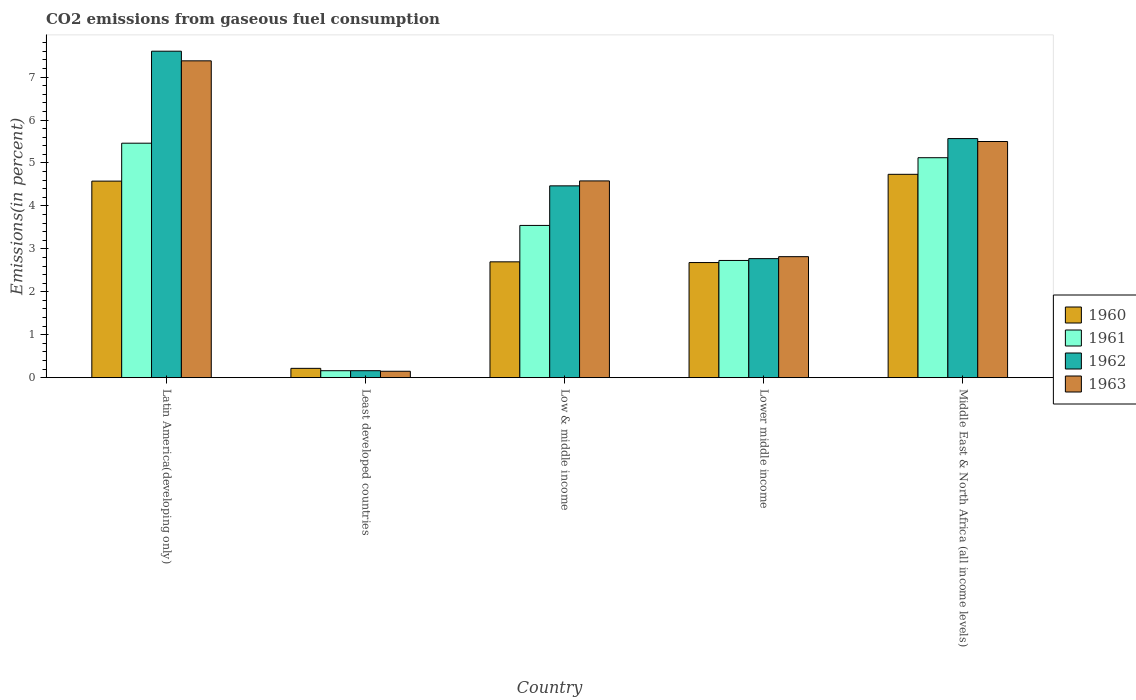How many different coloured bars are there?
Provide a succinct answer. 4. Are the number of bars per tick equal to the number of legend labels?
Provide a succinct answer. Yes. How many bars are there on the 4th tick from the left?
Your answer should be very brief. 4. How many bars are there on the 4th tick from the right?
Ensure brevity in your answer.  4. What is the label of the 5th group of bars from the left?
Your answer should be very brief. Middle East & North Africa (all income levels). What is the total CO2 emitted in 1962 in Low & middle income?
Your answer should be very brief. 4.47. Across all countries, what is the maximum total CO2 emitted in 1963?
Offer a very short reply. 7.38. Across all countries, what is the minimum total CO2 emitted in 1960?
Your answer should be compact. 0.22. In which country was the total CO2 emitted in 1960 maximum?
Provide a succinct answer. Middle East & North Africa (all income levels). In which country was the total CO2 emitted in 1961 minimum?
Your response must be concise. Least developed countries. What is the total total CO2 emitted in 1962 in the graph?
Offer a very short reply. 20.57. What is the difference between the total CO2 emitted in 1961 in Latin America(developing only) and that in Low & middle income?
Keep it short and to the point. 1.92. What is the difference between the total CO2 emitted in 1960 in Lower middle income and the total CO2 emitted in 1961 in Least developed countries?
Your answer should be very brief. 2.52. What is the average total CO2 emitted in 1961 per country?
Make the answer very short. 3.4. What is the difference between the total CO2 emitted of/in 1962 and total CO2 emitted of/in 1960 in Middle East & North Africa (all income levels)?
Make the answer very short. 0.83. In how many countries, is the total CO2 emitted in 1961 greater than 2.2 %?
Ensure brevity in your answer.  4. What is the ratio of the total CO2 emitted in 1962 in Least developed countries to that in Middle East & North Africa (all income levels)?
Make the answer very short. 0.03. Is the difference between the total CO2 emitted in 1962 in Least developed countries and Middle East & North Africa (all income levels) greater than the difference between the total CO2 emitted in 1960 in Least developed countries and Middle East & North Africa (all income levels)?
Offer a terse response. No. What is the difference between the highest and the second highest total CO2 emitted in 1961?
Give a very brief answer. 1.58. What is the difference between the highest and the lowest total CO2 emitted in 1961?
Offer a very short reply. 5.3. Is the sum of the total CO2 emitted in 1960 in Least developed countries and Middle East & North Africa (all income levels) greater than the maximum total CO2 emitted in 1961 across all countries?
Ensure brevity in your answer.  No. Is it the case that in every country, the sum of the total CO2 emitted in 1962 and total CO2 emitted in 1963 is greater than the sum of total CO2 emitted in 1961 and total CO2 emitted in 1960?
Offer a terse response. No. How many bars are there?
Keep it short and to the point. 20. Are all the bars in the graph horizontal?
Keep it short and to the point. No. How many countries are there in the graph?
Provide a short and direct response. 5. What is the difference between two consecutive major ticks on the Y-axis?
Provide a short and direct response. 1. Are the values on the major ticks of Y-axis written in scientific E-notation?
Your answer should be very brief. No. Does the graph contain any zero values?
Offer a very short reply. No. How are the legend labels stacked?
Your answer should be very brief. Vertical. What is the title of the graph?
Offer a very short reply. CO2 emissions from gaseous fuel consumption. Does "1983" appear as one of the legend labels in the graph?
Keep it short and to the point. No. What is the label or title of the X-axis?
Your answer should be compact. Country. What is the label or title of the Y-axis?
Your response must be concise. Emissions(in percent). What is the Emissions(in percent) of 1960 in Latin America(developing only)?
Give a very brief answer. 4.58. What is the Emissions(in percent) in 1961 in Latin America(developing only)?
Offer a terse response. 5.46. What is the Emissions(in percent) in 1962 in Latin America(developing only)?
Offer a very short reply. 7.6. What is the Emissions(in percent) of 1963 in Latin America(developing only)?
Offer a terse response. 7.38. What is the Emissions(in percent) of 1960 in Least developed countries?
Offer a terse response. 0.22. What is the Emissions(in percent) of 1961 in Least developed countries?
Offer a very short reply. 0.16. What is the Emissions(in percent) in 1962 in Least developed countries?
Keep it short and to the point. 0.16. What is the Emissions(in percent) in 1963 in Least developed countries?
Offer a very short reply. 0.15. What is the Emissions(in percent) of 1960 in Low & middle income?
Your answer should be very brief. 2.7. What is the Emissions(in percent) in 1961 in Low & middle income?
Give a very brief answer. 3.55. What is the Emissions(in percent) of 1962 in Low & middle income?
Offer a very short reply. 4.47. What is the Emissions(in percent) of 1963 in Low & middle income?
Offer a terse response. 4.58. What is the Emissions(in percent) in 1960 in Lower middle income?
Your answer should be very brief. 2.68. What is the Emissions(in percent) of 1961 in Lower middle income?
Offer a terse response. 2.73. What is the Emissions(in percent) of 1962 in Lower middle income?
Provide a short and direct response. 2.77. What is the Emissions(in percent) in 1963 in Lower middle income?
Keep it short and to the point. 2.82. What is the Emissions(in percent) of 1960 in Middle East & North Africa (all income levels)?
Keep it short and to the point. 4.74. What is the Emissions(in percent) in 1961 in Middle East & North Africa (all income levels)?
Your answer should be very brief. 5.12. What is the Emissions(in percent) of 1962 in Middle East & North Africa (all income levels)?
Offer a very short reply. 5.57. What is the Emissions(in percent) in 1963 in Middle East & North Africa (all income levels)?
Keep it short and to the point. 5.5. Across all countries, what is the maximum Emissions(in percent) in 1960?
Offer a terse response. 4.74. Across all countries, what is the maximum Emissions(in percent) in 1961?
Keep it short and to the point. 5.46. Across all countries, what is the maximum Emissions(in percent) of 1962?
Keep it short and to the point. 7.6. Across all countries, what is the maximum Emissions(in percent) of 1963?
Your response must be concise. 7.38. Across all countries, what is the minimum Emissions(in percent) of 1960?
Offer a terse response. 0.22. Across all countries, what is the minimum Emissions(in percent) of 1961?
Your response must be concise. 0.16. Across all countries, what is the minimum Emissions(in percent) in 1962?
Ensure brevity in your answer.  0.16. Across all countries, what is the minimum Emissions(in percent) in 1963?
Provide a short and direct response. 0.15. What is the total Emissions(in percent) in 1960 in the graph?
Give a very brief answer. 14.91. What is the total Emissions(in percent) in 1961 in the graph?
Offer a very short reply. 17.02. What is the total Emissions(in percent) in 1962 in the graph?
Offer a terse response. 20.57. What is the total Emissions(in percent) in 1963 in the graph?
Ensure brevity in your answer.  20.43. What is the difference between the Emissions(in percent) of 1960 in Latin America(developing only) and that in Least developed countries?
Make the answer very short. 4.36. What is the difference between the Emissions(in percent) in 1961 in Latin America(developing only) and that in Least developed countries?
Give a very brief answer. 5.3. What is the difference between the Emissions(in percent) in 1962 in Latin America(developing only) and that in Least developed countries?
Your answer should be compact. 7.44. What is the difference between the Emissions(in percent) in 1963 in Latin America(developing only) and that in Least developed countries?
Your response must be concise. 7.23. What is the difference between the Emissions(in percent) in 1960 in Latin America(developing only) and that in Low & middle income?
Offer a very short reply. 1.88. What is the difference between the Emissions(in percent) in 1961 in Latin America(developing only) and that in Low & middle income?
Keep it short and to the point. 1.92. What is the difference between the Emissions(in percent) of 1962 in Latin America(developing only) and that in Low & middle income?
Your answer should be very brief. 3.14. What is the difference between the Emissions(in percent) in 1963 in Latin America(developing only) and that in Low & middle income?
Make the answer very short. 2.8. What is the difference between the Emissions(in percent) of 1960 in Latin America(developing only) and that in Lower middle income?
Offer a very short reply. 1.9. What is the difference between the Emissions(in percent) of 1961 in Latin America(developing only) and that in Lower middle income?
Your answer should be compact. 2.73. What is the difference between the Emissions(in percent) in 1962 in Latin America(developing only) and that in Lower middle income?
Provide a short and direct response. 4.83. What is the difference between the Emissions(in percent) in 1963 in Latin America(developing only) and that in Lower middle income?
Provide a short and direct response. 4.56. What is the difference between the Emissions(in percent) in 1960 in Latin America(developing only) and that in Middle East & North Africa (all income levels)?
Make the answer very short. -0.16. What is the difference between the Emissions(in percent) of 1961 in Latin America(developing only) and that in Middle East & North Africa (all income levels)?
Your response must be concise. 0.34. What is the difference between the Emissions(in percent) of 1962 in Latin America(developing only) and that in Middle East & North Africa (all income levels)?
Offer a very short reply. 2.04. What is the difference between the Emissions(in percent) in 1963 in Latin America(developing only) and that in Middle East & North Africa (all income levels)?
Provide a short and direct response. 1.88. What is the difference between the Emissions(in percent) in 1960 in Least developed countries and that in Low & middle income?
Ensure brevity in your answer.  -2.48. What is the difference between the Emissions(in percent) of 1961 in Least developed countries and that in Low & middle income?
Make the answer very short. -3.38. What is the difference between the Emissions(in percent) in 1962 in Least developed countries and that in Low & middle income?
Keep it short and to the point. -4.31. What is the difference between the Emissions(in percent) of 1963 in Least developed countries and that in Low & middle income?
Keep it short and to the point. -4.43. What is the difference between the Emissions(in percent) of 1960 in Least developed countries and that in Lower middle income?
Provide a short and direct response. -2.46. What is the difference between the Emissions(in percent) in 1961 in Least developed countries and that in Lower middle income?
Ensure brevity in your answer.  -2.57. What is the difference between the Emissions(in percent) in 1962 in Least developed countries and that in Lower middle income?
Your answer should be very brief. -2.61. What is the difference between the Emissions(in percent) in 1963 in Least developed countries and that in Lower middle income?
Provide a succinct answer. -2.67. What is the difference between the Emissions(in percent) in 1960 in Least developed countries and that in Middle East & North Africa (all income levels)?
Offer a terse response. -4.52. What is the difference between the Emissions(in percent) of 1961 in Least developed countries and that in Middle East & North Africa (all income levels)?
Ensure brevity in your answer.  -4.96. What is the difference between the Emissions(in percent) in 1962 in Least developed countries and that in Middle East & North Africa (all income levels)?
Offer a very short reply. -5.41. What is the difference between the Emissions(in percent) of 1963 in Least developed countries and that in Middle East & North Africa (all income levels)?
Your response must be concise. -5.35. What is the difference between the Emissions(in percent) of 1960 in Low & middle income and that in Lower middle income?
Ensure brevity in your answer.  0.02. What is the difference between the Emissions(in percent) in 1961 in Low & middle income and that in Lower middle income?
Provide a short and direct response. 0.82. What is the difference between the Emissions(in percent) in 1962 in Low & middle income and that in Lower middle income?
Keep it short and to the point. 1.7. What is the difference between the Emissions(in percent) of 1963 in Low & middle income and that in Lower middle income?
Your answer should be compact. 1.76. What is the difference between the Emissions(in percent) of 1960 in Low & middle income and that in Middle East & North Africa (all income levels)?
Provide a succinct answer. -2.04. What is the difference between the Emissions(in percent) in 1961 in Low & middle income and that in Middle East & North Africa (all income levels)?
Keep it short and to the point. -1.58. What is the difference between the Emissions(in percent) in 1962 in Low & middle income and that in Middle East & North Africa (all income levels)?
Make the answer very short. -1.1. What is the difference between the Emissions(in percent) in 1963 in Low & middle income and that in Middle East & North Africa (all income levels)?
Provide a short and direct response. -0.92. What is the difference between the Emissions(in percent) in 1960 in Lower middle income and that in Middle East & North Africa (all income levels)?
Make the answer very short. -2.06. What is the difference between the Emissions(in percent) of 1961 in Lower middle income and that in Middle East & North Africa (all income levels)?
Your response must be concise. -2.39. What is the difference between the Emissions(in percent) in 1962 in Lower middle income and that in Middle East & North Africa (all income levels)?
Your answer should be very brief. -2.8. What is the difference between the Emissions(in percent) of 1963 in Lower middle income and that in Middle East & North Africa (all income levels)?
Your answer should be compact. -2.68. What is the difference between the Emissions(in percent) of 1960 in Latin America(developing only) and the Emissions(in percent) of 1961 in Least developed countries?
Offer a very short reply. 4.42. What is the difference between the Emissions(in percent) in 1960 in Latin America(developing only) and the Emissions(in percent) in 1962 in Least developed countries?
Give a very brief answer. 4.42. What is the difference between the Emissions(in percent) in 1960 in Latin America(developing only) and the Emissions(in percent) in 1963 in Least developed countries?
Offer a terse response. 4.43. What is the difference between the Emissions(in percent) in 1961 in Latin America(developing only) and the Emissions(in percent) in 1962 in Least developed countries?
Your response must be concise. 5.3. What is the difference between the Emissions(in percent) in 1961 in Latin America(developing only) and the Emissions(in percent) in 1963 in Least developed countries?
Your answer should be compact. 5.31. What is the difference between the Emissions(in percent) of 1962 in Latin America(developing only) and the Emissions(in percent) of 1963 in Least developed countries?
Keep it short and to the point. 7.45. What is the difference between the Emissions(in percent) in 1960 in Latin America(developing only) and the Emissions(in percent) in 1961 in Low & middle income?
Provide a succinct answer. 1.03. What is the difference between the Emissions(in percent) of 1960 in Latin America(developing only) and the Emissions(in percent) of 1962 in Low & middle income?
Offer a terse response. 0.11. What is the difference between the Emissions(in percent) of 1960 in Latin America(developing only) and the Emissions(in percent) of 1963 in Low & middle income?
Your answer should be compact. -0. What is the difference between the Emissions(in percent) in 1961 in Latin America(developing only) and the Emissions(in percent) in 1962 in Low & middle income?
Your response must be concise. 0.99. What is the difference between the Emissions(in percent) of 1961 in Latin America(developing only) and the Emissions(in percent) of 1963 in Low & middle income?
Offer a very short reply. 0.88. What is the difference between the Emissions(in percent) in 1962 in Latin America(developing only) and the Emissions(in percent) in 1963 in Low & middle income?
Ensure brevity in your answer.  3.02. What is the difference between the Emissions(in percent) of 1960 in Latin America(developing only) and the Emissions(in percent) of 1961 in Lower middle income?
Make the answer very short. 1.85. What is the difference between the Emissions(in percent) in 1960 in Latin America(developing only) and the Emissions(in percent) in 1962 in Lower middle income?
Keep it short and to the point. 1.81. What is the difference between the Emissions(in percent) of 1960 in Latin America(developing only) and the Emissions(in percent) of 1963 in Lower middle income?
Offer a terse response. 1.76. What is the difference between the Emissions(in percent) in 1961 in Latin America(developing only) and the Emissions(in percent) in 1962 in Lower middle income?
Ensure brevity in your answer.  2.69. What is the difference between the Emissions(in percent) in 1961 in Latin America(developing only) and the Emissions(in percent) in 1963 in Lower middle income?
Your response must be concise. 2.64. What is the difference between the Emissions(in percent) of 1962 in Latin America(developing only) and the Emissions(in percent) of 1963 in Lower middle income?
Keep it short and to the point. 4.79. What is the difference between the Emissions(in percent) in 1960 in Latin America(developing only) and the Emissions(in percent) in 1961 in Middle East & North Africa (all income levels)?
Keep it short and to the point. -0.54. What is the difference between the Emissions(in percent) of 1960 in Latin America(developing only) and the Emissions(in percent) of 1962 in Middle East & North Africa (all income levels)?
Keep it short and to the point. -0.99. What is the difference between the Emissions(in percent) of 1960 in Latin America(developing only) and the Emissions(in percent) of 1963 in Middle East & North Africa (all income levels)?
Keep it short and to the point. -0.92. What is the difference between the Emissions(in percent) of 1961 in Latin America(developing only) and the Emissions(in percent) of 1962 in Middle East & North Africa (all income levels)?
Ensure brevity in your answer.  -0.11. What is the difference between the Emissions(in percent) in 1961 in Latin America(developing only) and the Emissions(in percent) in 1963 in Middle East & North Africa (all income levels)?
Provide a short and direct response. -0.04. What is the difference between the Emissions(in percent) in 1962 in Latin America(developing only) and the Emissions(in percent) in 1963 in Middle East & North Africa (all income levels)?
Your answer should be compact. 2.1. What is the difference between the Emissions(in percent) of 1960 in Least developed countries and the Emissions(in percent) of 1961 in Low & middle income?
Offer a terse response. -3.33. What is the difference between the Emissions(in percent) of 1960 in Least developed countries and the Emissions(in percent) of 1962 in Low & middle income?
Provide a short and direct response. -4.25. What is the difference between the Emissions(in percent) of 1960 in Least developed countries and the Emissions(in percent) of 1963 in Low & middle income?
Provide a succinct answer. -4.37. What is the difference between the Emissions(in percent) in 1961 in Least developed countries and the Emissions(in percent) in 1962 in Low & middle income?
Offer a terse response. -4.31. What is the difference between the Emissions(in percent) of 1961 in Least developed countries and the Emissions(in percent) of 1963 in Low & middle income?
Give a very brief answer. -4.42. What is the difference between the Emissions(in percent) of 1962 in Least developed countries and the Emissions(in percent) of 1963 in Low & middle income?
Your answer should be compact. -4.42. What is the difference between the Emissions(in percent) in 1960 in Least developed countries and the Emissions(in percent) in 1961 in Lower middle income?
Ensure brevity in your answer.  -2.51. What is the difference between the Emissions(in percent) of 1960 in Least developed countries and the Emissions(in percent) of 1962 in Lower middle income?
Ensure brevity in your answer.  -2.56. What is the difference between the Emissions(in percent) in 1960 in Least developed countries and the Emissions(in percent) in 1963 in Lower middle income?
Provide a short and direct response. -2.6. What is the difference between the Emissions(in percent) in 1961 in Least developed countries and the Emissions(in percent) in 1962 in Lower middle income?
Make the answer very short. -2.61. What is the difference between the Emissions(in percent) in 1961 in Least developed countries and the Emissions(in percent) in 1963 in Lower middle income?
Your response must be concise. -2.66. What is the difference between the Emissions(in percent) of 1962 in Least developed countries and the Emissions(in percent) of 1963 in Lower middle income?
Provide a succinct answer. -2.66. What is the difference between the Emissions(in percent) in 1960 in Least developed countries and the Emissions(in percent) in 1961 in Middle East & North Africa (all income levels)?
Offer a terse response. -4.91. What is the difference between the Emissions(in percent) in 1960 in Least developed countries and the Emissions(in percent) in 1962 in Middle East & North Africa (all income levels)?
Your answer should be compact. -5.35. What is the difference between the Emissions(in percent) of 1960 in Least developed countries and the Emissions(in percent) of 1963 in Middle East & North Africa (all income levels)?
Provide a succinct answer. -5.28. What is the difference between the Emissions(in percent) in 1961 in Least developed countries and the Emissions(in percent) in 1962 in Middle East & North Africa (all income levels)?
Make the answer very short. -5.41. What is the difference between the Emissions(in percent) of 1961 in Least developed countries and the Emissions(in percent) of 1963 in Middle East & North Africa (all income levels)?
Provide a short and direct response. -5.34. What is the difference between the Emissions(in percent) of 1962 in Least developed countries and the Emissions(in percent) of 1963 in Middle East & North Africa (all income levels)?
Your answer should be compact. -5.34. What is the difference between the Emissions(in percent) in 1960 in Low & middle income and the Emissions(in percent) in 1961 in Lower middle income?
Your answer should be very brief. -0.03. What is the difference between the Emissions(in percent) of 1960 in Low & middle income and the Emissions(in percent) of 1962 in Lower middle income?
Your answer should be very brief. -0.07. What is the difference between the Emissions(in percent) in 1960 in Low & middle income and the Emissions(in percent) in 1963 in Lower middle income?
Your response must be concise. -0.12. What is the difference between the Emissions(in percent) of 1961 in Low & middle income and the Emissions(in percent) of 1962 in Lower middle income?
Provide a short and direct response. 0.77. What is the difference between the Emissions(in percent) in 1961 in Low & middle income and the Emissions(in percent) in 1963 in Lower middle income?
Provide a short and direct response. 0.73. What is the difference between the Emissions(in percent) of 1962 in Low & middle income and the Emissions(in percent) of 1963 in Lower middle income?
Offer a very short reply. 1.65. What is the difference between the Emissions(in percent) in 1960 in Low & middle income and the Emissions(in percent) in 1961 in Middle East & North Africa (all income levels)?
Your answer should be compact. -2.42. What is the difference between the Emissions(in percent) in 1960 in Low & middle income and the Emissions(in percent) in 1962 in Middle East & North Africa (all income levels)?
Keep it short and to the point. -2.87. What is the difference between the Emissions(in percent) of 1960 in Low & middle income and the Emissions(in percent) of 1963 in Middle East & North Africa (all income levels)?
Your answer should be very brief. -2.8. What is the difference between the Emissions(in percent) of 1961 in Low & middle income and the Emissions(in percent) of 1962 in Middle East & North Africa (all income levels)?
Your answer should be compact. -2.02. What is the difference between the Emissions(in percent) of 1961 in Low & middle income and the Emissions(in percent) of 1963 in Middle East & North Africa (all income levels)?
Provide a short and direct response. -1.95. What is the difference between the Emissions(in percent) of 1962 in Low & middle income and the Emissions(in percent) of 1963 in Middle East & North Africa (all income levels)?
Your answer should be compact. -1.03. What is the difference between the Emissions(in percent) in 1960 in Lower middle income and the Emissions(in percent) in 1961 in Middle East & North Africa (all income levels)?
Provide a short and direct response. -2.44. What is the difference between the Emissions(in percent) of 1960 in Lower middle income and the Emissions(in percent) of 1962 in Middle East & North Africa (all income levels)?
Give a very brief answer. -2.89. What is the difference between the Emissions(in percent) in 1960 in Lower middle income and the Emissions(in percent) in 1963 in Middle East & North Africa (all income levels)?
Keep it short and to the point. -2.82. What is the difference between the Emissions(in percent) of 1961 in Lower middle income and the Emissions(in percent) of 1962 in Middle East & North Africa (all income levels)?
Make the answer very short. -2.84. What is the difference between the Emissions(in percent) in 1961 in Lower middle income and the Emissions(in percent) in 1963 in Middle East & North Africa (all income levels)?
Provide a short and direct response. -2.77. What is the difference between the Emissions(in percent) in 1962 in Lower middle income and the Emissions(in percent) in 1963 in Middle East & North Africa (all income levels)?
Make the answer very short. -2.73. What is the average Emissions(in percent) in 1960 per country?
Provide a short and direct response. 2.98. What is the average Emissions(in percent) in 1961 per country?
Provide a short and direct response. 3.4. What is the average Emissions(in percent) in 1962 per country?
Ensure brevity in your answer.  4.11. What is the average Emissions(in percent) in 1963 per country?
Offer a very short reply. 4.09. What is the difference between the Emissions(in percent) in 1960 and Emissions(in percent) in 1961 in Latin America(developing only)?
Give a very brief answer. -0.88. What is the difference between the Emissions(in percent) in 1960 and Emissions(in percent) in 1962 in Latin America(developing only)?
Your answer should be very brief. -3.03. What is the difference between the Emissions(in percent) of 1960 and Emissions(in percent) of 1963 in Latin America(developing only)?
Provide a succinct answer. -2.8. What is the difference between the Emissions(in percent) of 1961 and Emissions(in percent) of 1962 in Latin America(developing only)?
Offer a terse response. -2.14. What is the difference between the Emissions(in percent) of 1961 and Emissions(in percent) of 1963 in Latin America(developing only)?
Provide a succinct answer. -1.92. What is the difference between the Emissions(in percent) of 1962 and Emissions(in percent) of 1963 in Latin America(developing only)?
Ensure brevity in your answer.  0.22. What is the difference between the Emissions(in percent) in 1960 and Emissions(in percent) in 1961 in Least developed countries?
Your answer should be compact. 0.05. What is the difference between the Emissions(in percent) in 1960 and Emissions(in percent) in 1962 in Least developed countries?
Provide a short and direct response. 0.05. What is the difference between the Emissions(in percent) of 1960 and Emissions(in percent) of 1963 in Least developed countries?
Your response must be concise. 0.07. What is the difference between the Emissions(in percent) in 1961 and Emissions(in percent) in 1962 in Least developed countries?
Give a very brief answer. -0. What is the difference between the Emissions(in percent) of 1961 and Emissions(in percent) of 1963 in Least developed countries?
Offer a very short reply. 0.01. What is the difference between the Emissions(in percent) of 1962 and Emissions(in percent) of 1963 in Least developed countries?
Your response must be concise. 0.01. What is the difference between the Emissions(in percent) of 1960 and Emissions(in percent) of 1961 in Low & middle income?
Ensure brevity in your answer.  -0.85. What is the difference between the Emissions(in percent) of 1960 and Emissions(in percent) of 1962 in Low & middle income?
Ensure brevity in your answer.  -1.77. What is the difference between the Emissions(in percent) of 1960 and Emissions(in percent) of 1963 in Low & middle income?
Give a very brief answer. -1.88. What is the difference between the Emissions(in percent) of 1961 and Emissions(in percent) of 1962 in Low & middle income?
Your response must be concise. -0.92. What is the difference between the Emissions(in percent) of 1961 and Emissions(in percent) of 1963 in Low & middle income?
Keep it short and to the point. -1.04. What is the difference between the Emissions(in percent) of 1962 and Emissions(in percent) of 1963 in Low & middle income?
Keep it short and to the point. -0.12. What is the difference between the Emissions(in percent) of 1960 and Emissions(in percent) of 1961 in Lower middle income?
Provide a succinct answer. -0.05. What is the difference between the Emissions(in percent) of 1960 and Emissions(in percent) of 1962 in Lower middle income?
Your response must be concise. -0.09. What is the difference between the Emissions(in percent) of 1960 and Emissions(in percent) of 1963 in Lower middle income?
Provide a short and direct response. -0.14. What is the difference between the Emissions(in percent) of 1961 and Emissions(in percent) of 1962 in Lower middle income?
Make the answer very short. -0.04. What is the difference between the Emissions(in percent) of 1961 and Emissions(in percent) of 1963 in Lower middle income?
Ensure brevity in your answer.  -0.09. What is the difference between the Emissions(in percent) of 1962 and Emissions(in percent) of 1963 in Lower middle income?
Make the answer very short. -0.05. What is the difference between the Emissions(in percent) in 1960 and Emissions(in percent) in 1961 in Middle East & North Africa (all income levels)?
Your response must be concise. -0.39. What is the difference between the Emissions(in percent) in 1960 and Emissions(in percent) in 1962 in Middle East & North Africa (all income levels)?
Your response must be concise. -0.83. What is the difference between the Emissions(in percent) of 1960 and Emissions(in percent) of 1963 in Middle East & North Africa (all income levels)?
Offer a very short reply. -0.76. What is the difference between the Emissions(in percent) of 1961 and Emissions(in percent) of 1962 in Middle East & North Africa (all income levels)?
Offer a terse response. -0.45. What is the difference between the Emissions(in percent) of 1961 and Emissions(in percent) of 1963 in Middle East & North Africa (all income levels)?
Give a very brief answer. -0.38. What is the difference between the Emissions(in percent) of 1962 and Emissions(in percent) of 1963 in Middle East & North Africa (all income levels)?
Your response must be concise. 0.07. What is the ratio of the Emissions(in percent) of 1960 in Latin America(developing only) to that in Least developed countries?
Provide a short and direct response. 21.12. What is the ratio of the Emissions(in percent) of 1961 in Latin America(developing only) to that in Least developed countries?
Offer a very short reply. 33.71. What is the ratio of the Emissions(in percent) of 1962 in Latin America(developing only) to that in Least developed countries?
Ensure brevity in your answer.  46.89. What is the ratio of the Emissions(in percent) in 1963 in Latin America(developing only) to that in Least developed countries?
Keep it short and to the point. 49.45. What is the ratio of the Emissions(in percent) in 1960 in Latin America(developing only) to that in Low & middle income?
Offer a terse response. 1.7. What is the ratio of the Emissions(in percent) of 1961 in Latin America(developing only) to that in Low & middle income?
Your response must be concise. 1.54. What is the ratio of the Emissions(in percent) of 1962 in Latin America(developing only) to that in Low & middle income?
Give a very brief answer. 1.7. What is the ratio of the Emissions(in percent) of 1963 in Latin America(developing only) to that in Low & middle income?
Your answer should be very brief. 1.61. What is the ratio of the Emissions(in percent) of 1960 in Latin America(developing only) to that in Lower middle income?
Your answer should be compact. 1.71. What is the ratio of the Emissions(in percent) of 1961 in Latin America(developing only) to that in Lower middle income?
Make the answer very short. 2. What is the ratio of the Emissions(in percent) in 1962 in Latin America(developing only) to that in Lower middle income?
Your answer should be compact. 2.74. What is the ratio of the Emissions(in percent) in 1963 in Latin America(developing only) to that in Lower middle income?
Give a very brief answer. 2.62. What is the ratio of the Emissions(in percent) in 1960 in Latin America(developing only) to that in Middle East & North Africa (all income levels)?
Your answer should be compact. 0.97. What is the ratio of the Emissions(in percent) of 1961 in Latin America(developing only) to that in Middle East & North Africa (all income levels)?
Offer a very short reply. 1.07. What is the ratio of the Emissions(in percent) of 1962 in Latin America(developing only) to that in Middle East & North Africa (all income levels)?
Offer a terse response. 1.37. What is the ratio of the Emissions(in percent) in 1963 in Latin America(developing only) to that in Middle East & North Africa (all income levels)?
Your answer should be very brief. 1.34. What is the ratio of the Emissions(in percent) of 1960 in Least developed countries to that in Low & middle income?
Your answer should be compact. 0.08. What is the ratio of the Emissions(in percent) of 1961 in Least developed countries to that in Low & middle income?
Offer a terse response. 0.05. What is the ratio of the Emissions(in percent) of 1962 in Least developed countries to that in Low & middle income?
Keep it short and to the point. 0.04. What is the ratio of the Emissions(in percent) in 1963 in Least developed countries to that in Low & middle income?
Keep it short and to the point. 0.03. What is the ratio of the Emissions(in percent) in 1960 in Least developed countries to that in Lower middle income?
Provide a short and direct response. 0.08. What is the ratio of the Emissions(in percent) in 1961 in Least developed countries to that in Lower middle income?
Give a very brief answer. 0.06. What is the ratio of the Emissions(in percent) of 1962 in Least developed countries to that in Lower middle income?
Keep it short and to the point. 0.06. What is the ratio of the Emissions(in percent) of 1963 in Least developed countries to that in Lower middle income?
Keep it short and to the point. 0.05. What is the ratio of the Emissions(in percent) in 1960 in Least developed countries to that in Middle East & North Africa (all income levels)?
Your answer should be compact. 0.05. What is the ratio of the Emissions(in percent) of 1961 in Least developed countries to that in Middle East & North Africa (all income levels)?
Your answer should be compact. 0.03. What is the ratio of the Emissions(in percent) in 1962 in Least developed countries to that in Middle East & North Africa (all income levels)?
Your answer should be very brief. 0.03. What is the ratio of the Emissions(in percent) in 1963 in Least developed countries to that in Middle East & North Africa (all income levels)?
Keep it short and to the point. 0.03. What is the ratio of the Emissions(in percent) of 1960 in Low & middle income to that in Lower middle income?
Your answer should be very brief. 1.01. What is the ratio of the Emissions(in percent) in 1961 in Low & middle income to that in Lower middle income?
Ensure brevity in your answer.  1.3. What is the ratio of the Emissions(in percent) of 1962 in Low & middle income to that in Lower middle income?
Offer a terse response. 1.61. What is the ratio of the Emissions(in percent) in 1963 in Low & middle income to that in Lower middle income?
Keep it short and to the point. 1.63. What is the ratio of the Emissions(in percent) in 1960 in Low & middle income to that in Middle East & North Africa (all income levels)?
Give a very brief answer. 0.57. What is the ratio of the Emissions(in percent) of 1961 in Low & middle income to that in Middle East & North Africa (all income levels)?
Your response must be concise. 0.69. What is the ratio of the Emissions(in percent) in 1962 in Low & middle income to that in Middle East & North Africa (all income levels)?
Your answer should be compact. 0.8. What is the ratio of the Emissions(in percent) in 1963 in Low & middle income to that in Middle East & North Africa (all income levels)?
Your answer should be very brief. 0.83. What is the ratio of the Emissions(in percent) in 1960 in Lower middle income to that in Middle East & North Africa (all income levels)?
Provide a succinct answer. 0.57. What is the ratio of the Emissions(in percent) in 1961 in Lower middle income to that in Middle East & North Africa (all income levels)?
Your response must be concise. 0.53. What is the ratio of the Emissions(in percent) of 1962 in Lower middle income to that in Middle East & North Africa (all income levels)?
Offer a very short reply. 0.5. What is the ratio of the Emissions(in percent) of 1963 in Lower middle income to that in Middle East & North Africa (all income levels)?
Provide a succinct answer. 0.51. What is the difference between the highest and the second highest Emissions(in percent) of 1960?
Offer a terse response. 0.16. What is the difference between the highest and the second highest Emissions(in percent) of 1961?
Give a very brief answer. 0.34. What is the difference between the highest and the second highest Emissions(in percent) of 1962?
Ensure brevity in your answer.  2.04. What is the difference between the highest and the second highest Emissions(in percent) in 1963?
Your response must be concise. 1.88. What is the difference between the highest and the lowest Emissions(in percent) of 1960?
Provide a short and direct response. 4.52. What is the difference between the highest and the lowest Emissions(in percent) in 1961?
Make the answer very short. 5.3. What is the difference between the highest and the lowest Emissions(in percent) of 1962?
Provide a short and direct response. 7.44. What is the difference between the highest and the lowest Emissions(in percent) in 1963?
Provide a short and direct response. 7.23. 